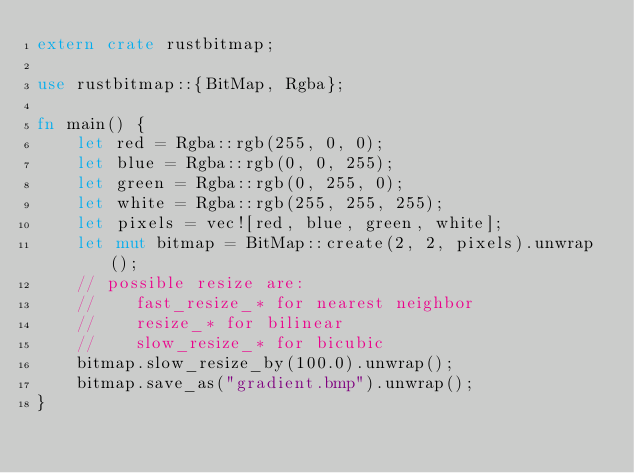Convert code to text. <code><loc_0><loc_0><loc_500><loc_500><_Rust_>extern crate rustbitmap;

use rustbitmap::{BitMap, Rgba};

fn main() {
    let red = Rgba::rgb(255, 0, 0);
    let blue = Rgba::rgb(0, 0, 255);
    let green = Rgba::rgb(0, 255, 0);
    let white = Rgba::rgb(255, 255, 255);
    let pixels = vec![red, blue, green, white];
    let mut bitmap = BitMap::create(2, 2, pixels).unwrap();
    // possible resize are:
    //    fast_resize_* for nearest neighbor
    //    resize_* for bilinear
    //    slow_resize_* for bicubic
    bitmap.slow_resize_by(100.0).unwrap();
    bitmap.save_as("gradient.bmp").unwrap();
}
</code> 